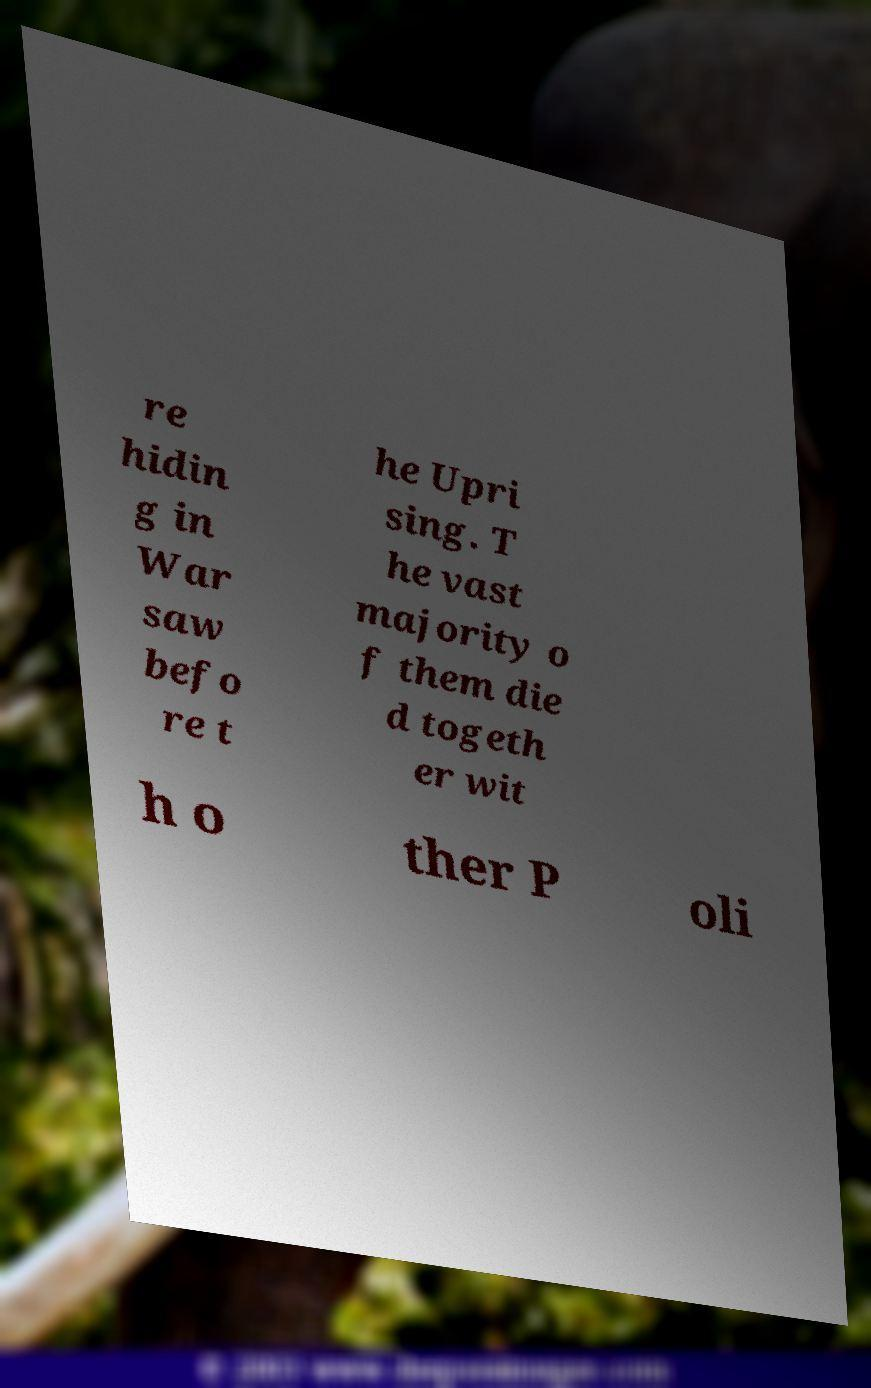What messages or text are displayed in this image? I need them in a readable, typed format. re hidin g in War saw befo re t he Upri sing. T he vast majority o f them die d togeth er wit h o ther P oli 